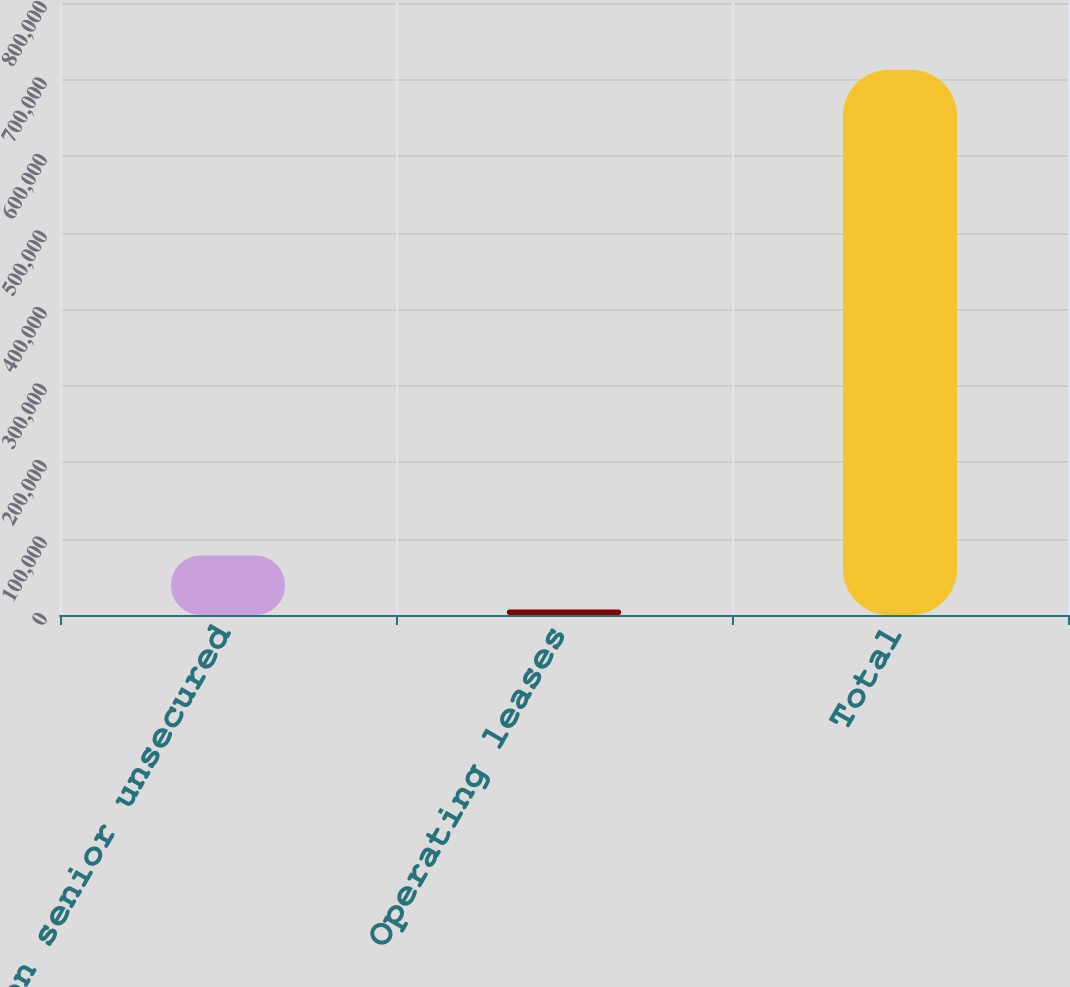Convert chart. <chart><loc_0><loc_0><loc_500><loc_500><bar_chart><fcel>Interest on senior unsecured<fcel>Operating leases<fcel>Total<nl><fcel>77805.5<fcel>7259<fcel>712724<nl></chart> 